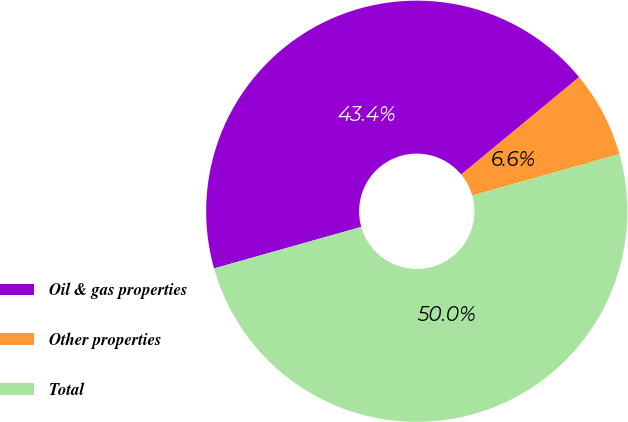Convert chart to OTSL. <chart><loc_0><loc_0><loc_500><loc_500><pie_chart><fcel>Oil & gas properties<fcel>Other properties<fcel>Total<nl><fcel>43.39%<fcel>6.61%<fcel>50.0%<nl></chart> 